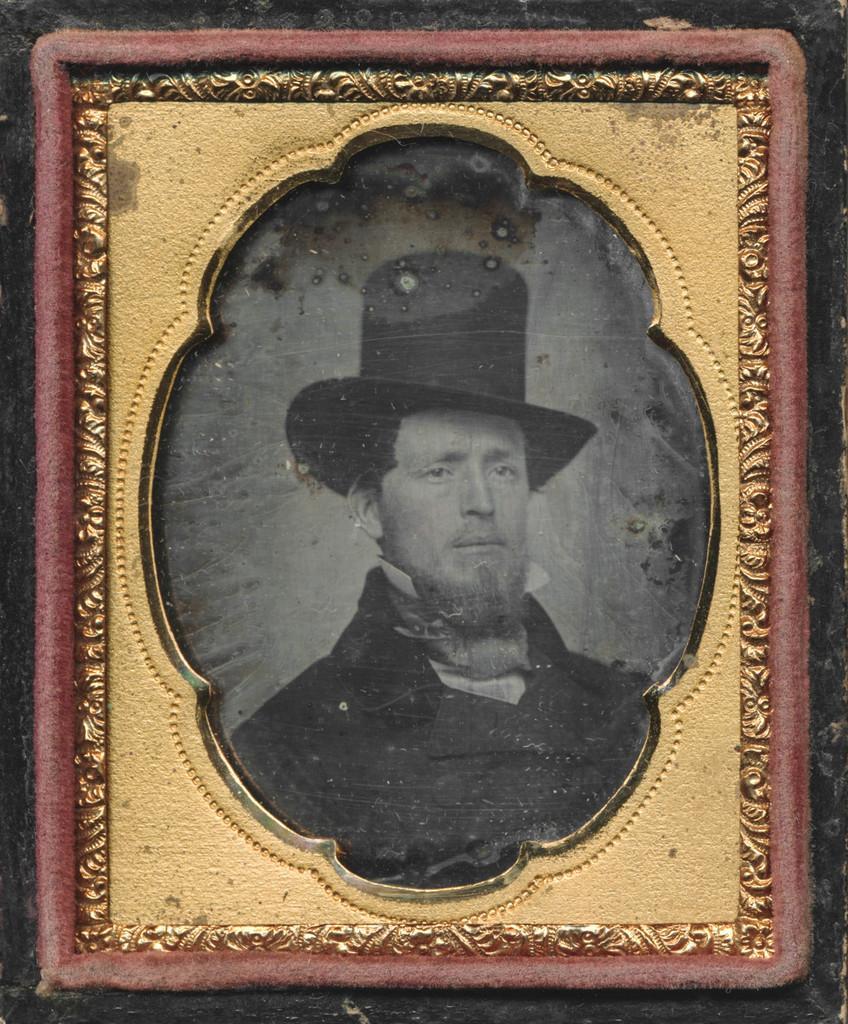Describe this image in one or two sentences. In the image there is a black and white painting of a man in a frame on the wall. 